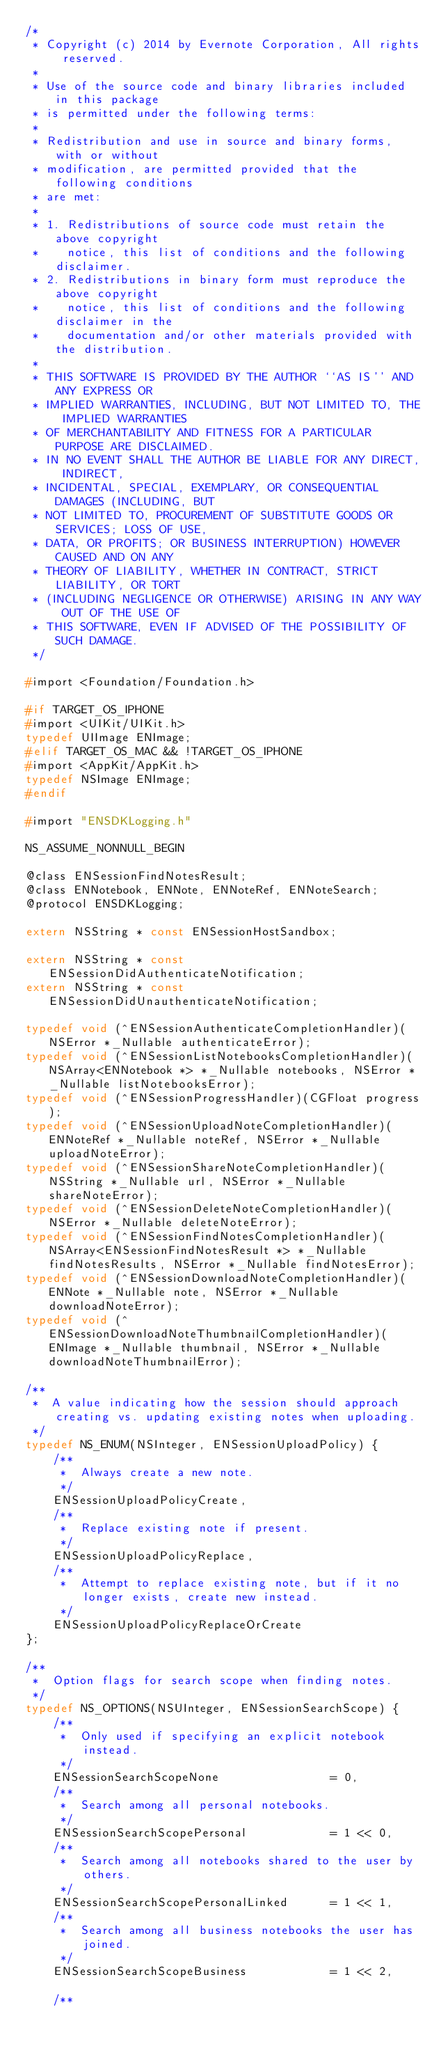<code> <loc_0><loc_0><loc_500><loc_500><_C_>/*
 * Copyright (c) 2014 by Evernote Corporation, All rights reserved.
 *
 * Use of the source code and binary libraries included in this package
 * is permitted under the following terms:
 *
 * Redistribution and use in source and binary forms, with or without
 * modification, are permitted provided that the following conditions
 * are met:
 *
 * 1. Redistributions of source code must retain the above copyright
 *    notice, this list of conditions and the following disclaimer.
 * 2. Redistributions in binary form must reproduce the above copyright
 *    notice, this list of conditions and the following disclaimer in the
 *    documentation and/or other materials provided with the distribution.
 *
 * THIS SOFTWARE IS PROVIDED BY THE AUTHOR ``AS IS'' AND ANY EXPRESS OR
 * IMPLIED WARRANTIES, INCLUDING, BUT NOT LIMITED TO, THE IMPLIED WARRANTIES
 * OF MERCHANTABILITY AND FITNESS FOR A PARTICULAR PURPOSE ARE DISCLAIMED.
 * IN NO EVENT SHALL THE AUTHOR BE LIABLE FOR ANY DIRECT, INDIRECT,
 * INCIDENTAL, SPECIAL, EXEMPLARY, OR CONSEQUENTIAL DAMAGES (INCLUDING, BUT
 * NOT LIMITED TO, PROCUREMENT OF SUBSTITUTE GOODS OR SERVICES; LOSS OF USE,
 * DATA, OR PROFITS; OR BUSINESS INTERRUPTION) HOWEVER CAUSED AND ON ANY
 * THEORY OF LIABILITY, WHETHER IN CONTRACT, STRICT LIABILITY, OR TORT
 * (INCLUDING NEGLIGENCE OR OTHERWISE) ARISING IN ANY WAY OUT OF THE USE OF
 * THIS SOFTWARE, EVEN IF ADVISED OF THE POSSIBILITY OF SUCH DAMAGE.
 */

#import <Foundation/Foundation.h>

#if TARGET_OS_IPHONE
#import <UIKit/UIKit.h>
typedef UIImage ENImage;
#elif TARGET_OS_MAC && !TARGET_OS_IPHONE
#import <AppKit/AppKit.h>
typedef NSImage ENImage;
#endif

#import "ENSDKLogging.h"

NS_ASSUME_NONNULL_BEGIN

@class ENSessionFindNotesResult;
@class ENNotebook, ENNote, ENNoteRef, ENNoteSearch;
@protocol ENSDKLogging;

extern NSString * const ENSessionHostSandbox;

extern NSString * const ENSessionDidAuthenticateNotification;
extern NSString * const ENSessionDidUnauthenticateNotification;

typedef void (^ENSessionAuthenticateCompletionHandler)(NSError *_Nullable authenticateError);
typedef void (^ENSessionListNotebooksCompletionHandler)(NSArray<ENNotebook *> *_Nullable notebooks, NSError *_Nullable listNotebooksError);
typedef void (^ENSessionProgressHandler)(CGFloat progress);
typedef void (^ENSessionUploadNoteCompletionHandler)(ENNoteRef *_Nullable noteRef, NSError *_Nullable uploadNoteError);
typedef void (^ENSessionShareNoteCompletionHandler)(NSString *_Nullable url, NSError *_Nullable shareNoteError);
typedef void (^ENSessionDeleteNoteCompletionHandler)(NSError *_Nullable deleteNoteError);
typedef void (^ENSessionFindNotesCompletionHandler)(NSArray<ENSessionFindNotesResult *> *_Nullable findNotesResults, NSError *_Nullable findNotesError);
typedef void (^ENSessionDownloadNoteCompletionHandler)(ENNote *_Nullable note, NSError *_Nullable downloadNoteError);
typedef void (^ENSessionDownloadNoteThumbnailCompletionHandler)(ENImage *_Nullable thumbnail, NSError *_Nullable downloadNoteThumbnailError);

/**
 *  A value indicating how the session should approach creating vs. updating existing notes when uploading.
 */
typedef NS_ENUM(NSInteger, ENSessionUploadPolicy) {
    /**
     *  Always create a new note.
     */
    ENSessionUploadPolicyCreate,
    /**
     *  Replace existing note if present.
     */
    ENSessionUploadPolicyReplace,
    /**
     *  Attempt to replace existing note, but if it no longer exists, create new instead.
     */
    ENSessionUploadPolicyReplaceOrCreate
};

/**
 *  Option flags for search scope when finding notes.
 */
typedef NS_OPTIONS(NSUInteger, ENSessionSearchScope) {
    /**
     *  Only used if specifying an explicit notebook instead.
     */
    ENSessionSearchScopeNone                = 0,
    /**
     *  Search among all personal notebooks.
     */
    ENSessionSearchScopePersonal            = 1 << 0,
    /**
     *  Search among all notebooks shared to the user by others.
     */
    ENSessionSearchScopePersonalLinked      = 1 << 1,
    /**
     *  Search among all business notebooks the user has joined.
     */
    ENSessionSearchScopeBusiness            = 1 << 2,

    /**</code> 